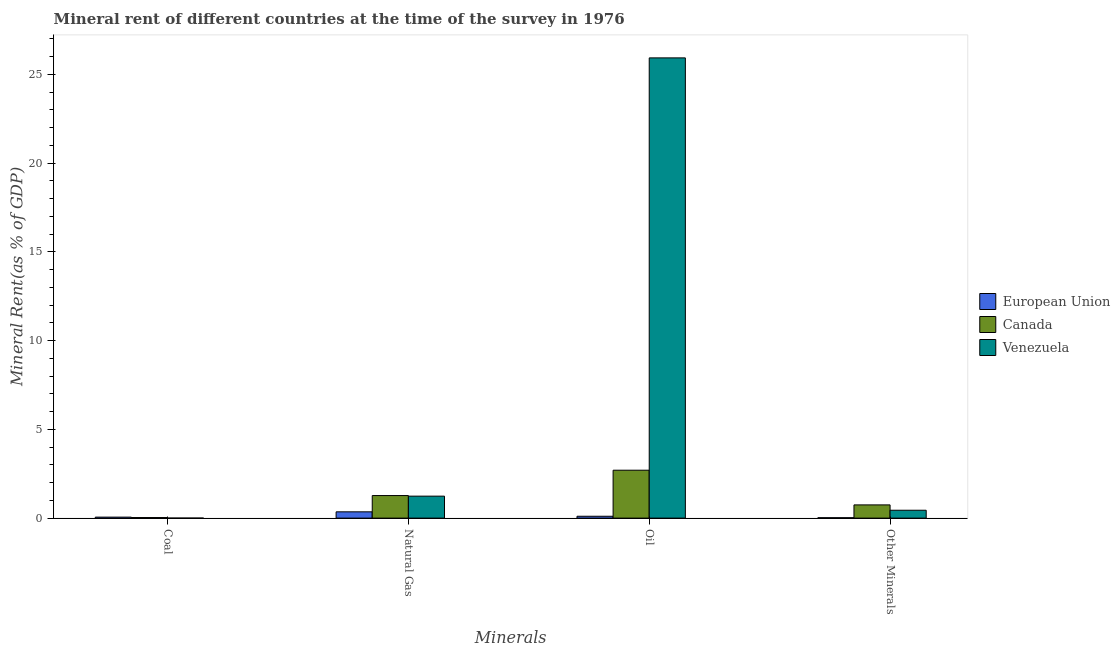How many different coloured bars are there?
Give a very brief answer. 3. Are the number of bars per tick equal to the number of legend labels?
Provide a short and direct response. Yes. Are the number of bars on each tick of the X-axis equal?
Keep it short and to the point. Yes. How many bars are there on the 1st tick from the left?
Keep it short and to the point. 3. How many bars are there on the 4th tick from the right?
Give a very brief answer. 3. What is the label of the 3rd group of bars from the left?
Your answer should be very brief. Oil. What is the oil rent in Canada?
Make the answer very short. 2.7. Across all countries, what is the maximum natural gas rent?
Provide a succinct answer. 1.27. Across all countries, what is the minimum  rent of other minerals?
Ensure brevity in your answer.  0.02. In which country was the natural gas rent maximum?
Provide a succinct answer. Canada. What is the total coal rent in the graph?
Your answer should be very brief. 0.09. What is the difference between the oil rent in Venezuela and that in Canada?
Your answer should be compact. 23.23. What is the difference between the natural gas rent in Venezuela and the coal rent in European Union?
Your response must be concise. 1.18. What is the average natural gas rent per country?
Keep it short and to the point. 0.95. What is the difference between the oil rent and coal rent in Canada?
Your answer should be compact. 2.67. What is the ratio of the oil rent in European Union to that in Canada?
Ensure brevity in your answer.  0.04. Is the oil rent in Venezuela less than that in European Union?
Ensure brevity in your answer.  No. Is the difference between the natural gas rent in Venezuela and European Union greater than the difference between the oil rent in Venezuela and European Union?
Your answer should be very brief. No. What is the difference between the highest and the second highest coal rent?
Your answer should be very brief. 0.02. What is the difference between the highest and the lowest  rent of other minerals?
Provide a succinct answer. 0.72. In how many countries, is the  rent of other minerals greater than the average  rent of other minerals taken over all countries?
Offer a very short reply. 2. Is the sum of the  rent of other minerals in Venezuela and European Union greater than the maximum natural gas rent across all countries?
Ensure brevity in your answer.  No. What does the 1st bar from the left in Oil represents?
Ensure brevity in your answer.  European Union. What does the 1st bar from the right in Natural Gas represents?
Your answer should be very brief. Venezuela. How many countries are there in the graph?
Keep it short and to the point. 3. Does the graph contain grids?
Your response must be concise. No. Where does the legend appear in the graph?
Your answer should be very brief. Center right. How many legend labels are there?
Provide a succinct answer. 3. How are the legend labels stacked?
Make the answer very short. Vertical. What is the title of the graph?
Ensure brevity in your answer.  Mineral rent of different countries at the time of the survey in 1976. What is the label or title of the X-axis?
Keep it short and to the point. Minerals. What is the label or title of the Y-axis?
Provide a succinct answer. Mineral Rent(as % of GDP). What is the Mineral Rent(as % of GDP) in European Union in Coal?
Provide a short and direct response. 0.06. What is the Mineral Rent(as % of GDP) of Canada in Coal?
Your response must be concise. 0.03. What is the Mineral Rent(as % of GDP) in Venezuela in Coal?
Provide a succinct answer. 0. What is the Mineral Rent(as % of GDP) of European Union in Natural Gas?
Your answer should be compact. 0.35. What is the Mineral Rent(as % of GDP) of Canada in Natural Gas?
Keep it short and to the point. 1.27. What is the Mineral Rent(as % of GDP) in Venezuela in Natural Gas?
Offer a very short reply. 1.24. What is the Mineral Rent(as % of GDP) in European Union in Oil?
Offer a very short reply. 0.11. What is the Mineral Rent(as % of GDP) of Canada in Oil?
Give a very brief answer. 2.7. What is the Mineral Rent(as % of GDP) in Venezuela in Oil?
Make the answer very short. 25.92. What is the Mineral Rent(as % of GDP) in European Union in Other Minerals?
Your answer should be compact. 0.02. What is the Mineral Rent(as % of GDP) of Canada in Other Minerals?
Your answer should be compact. 0.74. What is the Mineral Rent(as % of GDP) of Venezuela in Other Minerals?
Your answer should be compact. 0.44. Across all Minerals, what is the maximum Mineral Rent(as % of GDP) in European Union?
Your answer should be very brief. 0.35. Across all Minerals, what is the maximum Mineral Rent(as % of GDP) in Canada?
Provide a succinct answer. 2.7. Across all Minerals, what is the maximum Mineral Rent(as % of GDP) in Venezuela?
Ensure brevity in your answer.  25.92. Across all Minerals, what is the minimum Mineral Rent(as % of GDP) of European Union?
Provide a short and direct response. 0.02. Across all Minerals, what is the minimum Mineral Rent(as % of GDP) in Canada?
Ensure brevity in your answer.  0.03. Across all Minerals, what is the minimum Mineral Rent(as % of GDP) of Venezuela?
Ensure brevity in your answer.  0. What is the total Mineral Rent(as % of GDP) of European Union in the graph?
Keep it short and to the point. 0.54. What is the total Mineral Rent(as % of GDP) of Canada in the graph?
Your answer should be very brief. 4.75. What is the total Mineral Rent(as % of GDP) of Venezuela in the graph?
Provide a succinct answer. 27.61. What is the difference between the Mineral Rent(as % of GDP) of European Union in Coal and that in Natural Gas?
Your response must be concise. -0.3. What is the difference between the Mineral Rent(as % of GDP) of Canada in Coal and that in Natural Gas?
Make the answer very short. -1.24. What is the difference between the Mineral Rent(as % of GDP) of Venezuela in Coal and that in Natural Gas?
Offer a terse response. -1.24. What is the difference between the Mineral Rent(as % of GDP) of European Union in Coal and that in Oil?
Ensure brevity in your answer.  -0.05. What is the difference between the Mineral Rent(as % of GDP) in Canada in Coal and that in Oil?
Offer a very short reply. -2.67. What is the difference between the Mineral Rent(as % of GDP) in Venezuela in Coal and that in Oil?
Ensure brevity in your answer.  -25.92. What is the difference between the Mineral Rent(as % of GDP) of European Union in Coal and that in Other Minerals?
Your answer should be very brief. 0.03. What is the difference between the Mineral Rent(as % of GDP) in Canada in Coal and that in Other Minerals?
Provide a short and direct response. -0.71. What is the difference between the Mineral Rent(as % of GDP) of Venezuela in Coal and that in Other Minerals?
Provide a succinct answer. -0.44. What is the difference between the Mineral Rent(as % of GDP) in European Union in Natural Gas and that in Oil?
Make the answer very short. 0.25. What is the difference between the Mineral Rent(as % of GDP) in Canada in Natural Gas and that in Oil?
Your answer should be compact. -1.43. What is the difference between the Mineral Rent(as % of GDP) of Venezuela in Natural Gas and that in Oil?
Offer a terse response. -24.69. What is the difference between the Mineral Rent(as % of GDP) of European Union in Natural Gas and that in Other Minerals?
Keep it short and to the point. 0.33. What is the difference between the Mineral Rent(as % of GDP) of Canada in Natural Gas and that in Other Minerals?
Offer a very short reply. 0.53. What is the difference between the Mineral Rent(as % of GDP) in Venezuela in Natural Gas and that in Other Minerals?
Ensure brevity in your answer.  0.79. What is the difference between the Mineral Rent(as % of GDP) of European Union in Oil and that in Other Minerals?
Make the answer very short. 0.08. What is the difference between the Mineral Rent(as % of GDP) in Canada in Oil and that in Other Minerals?
Make the answer very short. 1.95. What is the difference between the Mineral Rent(as % of GDP) in Venezuela in Oil and that in Other Minerals?
Offer a terse response. 25.48. What is the difference between the Mineral Rent(as % of GDP) in European Union in Coal and the Mineral Rent(as % of GDP) in Canada in Natural Gas?
Ensure brevity in your answer.  -1.22. What is the difference between the Mineral Rent(as % of GDP) in European Union in Coal and the Mineral Rent(as % of GDP) in Venezuela in Natural Gas?
Give a very brief answer. -1.18. What is the difference between the Mineral Rent(as % of GDP) in Canada in Coal and the Mineral Rent(as % of GDP) in Venezuela in Natural Gas?
Provide a succinct answer. -1.21. What is the difference between the Mineral Rent(as % of GDP) in European Union in Coal and the Mineral Rent(as % of GDP) in Canada in Oil?
Provide a succinct answer. -2.64. What is the difference between the Mineral Rent(as % of GDP) in European Union in Coal and the Mineral Rent(as % of GDP) in Venezuela in Oil?
Offer a very short reply. -25.87. What is the difference between the Mineral Rent(as % of GDP) in Canada in Coal and the Mineral Rent(as % of GDP) in Venezuela in Oil?
Offer a very short reply. -25.89. What is the difference between the Mineral Rent(as % of GDP) in European Union in Coal and the Mineral Rent(as % of GDP) in Canada in Other Minerals?
Provide a succinct answer. -0.69. What is the difference between the Mineral Rent(as % of GDP) in European Union in Coal and the Mineral Rent(as % of GDP) in Venezuela in Other Minerals?
Provide a short and direct response. -0.39. What is the difference between the Mineral Rent(as % of GDP) of Canada in Coal and the Mineral Rent(as % of GDP) of Venezuela in Other Minerals?
Your answer should be compact. -0.41. What is the difference between the Mineral Rent(as % of GDP) in European Union in Natural Gas and the Mineral Rent(as % of GDP) in Canada in Oil?
Ensure brevity in your answer.  -2.34. What is the difference between the Mineral Rent(as % of GDP) in European Union in Natural Gas and the Mineral Rent(as % of GDP) in Venezuela in Oil?
Your answer should be very brief. -25.57. What is the difference between the Mineral Rent(as % of GDP) in Canada in Natural Gas and the Mineral Rent(as % of GDP) in Venezuela in Oil?
Ensure brevity in your answer.  -24.65. What is the difference between the Mineral Rent(as % of GDP) of European Union in Natural Gas and the Mineral Rent(as % of GDP) of Canada in Other Minerals?
Give a very brief answer. -0.39. What is the difference between the Mineral Rent(as % of GDP) of European Union in Natural Gas and the Mineral Rent(as % of GDP) of Venezuela in Other Minerals?
Keep it short and to the point. -0.09. What is the difference between the Mineral Rent(as % of GDP) in Canada in Natural Gas and the Mineral Rent(as % of GDP) in Venezuela in Other Minerals?
Offer a terse response. 0.83. What is the difference between the Mineral Rent(as % of GDP) of European Union in Oil and the Mineral Rent(as % of GDP) of Canada in Other Minerals?
Make the answer very short. -0.64. What is the difference between the Mineral Rent(as % of GDP) in European Union in Oil and the Mineral Rent(as % of GDP) in Venezuela in Other Minerals?
Make the answer very short. -0.34. What is the difference between the Mineral Rent(as % of GDP) of Canada in Oil and the Mineral Rent(as % of GDP) of Venezuela in Other Minerals?
Offer a terse response. 2.25. What is the average Mineral Rent(as % of GDP) of European Union per Minerals?
Offer a terse response. 0.13. What is the average Mineral Rent(as % of GDP) in Canada per Minerals?
Offer a terse response. 1.19. What is the average Mineral Rent(as % of GDP) in Venezuela per Minerals?
Make the answer very short. 6.9. What is the difference between the Mineral Rent(as % of GDP) in European Union and Mineral Rent(as % of GDP) in Canada in Coal?
Provide a succinct answer. 0.02. What is the difference between the Mineral Rent(as % of GDP) of European Union and Mineral Rent(as % of GDP) of Venezuela in Coal?
Offer a terse response. 0.05. What is the difference between the Mineral Rent(as % of GDP) of Canada and Mineral Rent(as % of GDP) of Venezuela in Coal?
Make the answer very short. 0.03. What is the difference between the Mineral Rent(as % of GDP) of European Union and Mineral Rent(as % of GDP) of Canada in Natural Gas?
Your answer should be very brief. -0.92. What is the difference between the Mineral Rent(as % of GDP) of European Union and Mineral Rent(as % of GDP) of Venezuela in Natural Gas?
Your answer should be compact. -0.88. What is the difference between the Mineral Rent(as % of GDP) of Canada and Mineral Rent(as % of GDP) of Venezuela in Natural Gas?
Ensure brevity in your answer.  0.03. What is the difference between the Mineral Rent(as % of GDP) in European Union and Mineral Rent(as % of GDP) in Canada in Oil?
Offer a very short reply. -2.59. What is the difference between the Mineral Rent(as % of GDP) in European Union and Mineral Rent(as % of GDP) in Venezuela in Oil?
Offer a terse response. -25.82. What is the difference between the Mineral Rent(as % of GDP) of Canada and Mineral Rent(as % of GDP) of Venezuela in Oil?
Give a very brief answer. -23.23. What is the difference between the Mineral Rent(as % of GDP) in European Union and Mineral Rent(as % of GDP) in Canada in Other Minerals?
Make the answer very short. -0.72. What is the difference between the Mineral Rent(as % of GDP) of European Union and Mineral Rent(as % of GDP) of Venezuela in Other Minerals?
Offer a very short reply. -0.42. What is the difference between the Mineral Rent(as % of GDP) of Canada and Mineral Rent(as % of GDP) of Venezuela in Other Minerals?
Your response must be concise. 0.3. What is the ratio of the Mineral Rent(as % of GDP) of European Union in Coal to that in Natural Gas?
Your answer should be compact. 0.16. What is the ratio of the Mineral Rent(as % of GDP) in Canada in Coal to that in Natural Gas?
Offer a terse response. 0.02. What is the ratio of the Mineral Rent(as % of GDP) in Venezuela in Coal to that in Natural Gas?
Your answer should be very brief. 0. What is the ratio of the Mineral Rent(as % of GDP) of European Union in Coal to that in Oil?
Ensure brevity in your answer.  0.53. What is the ratio of the Mineral Rent(as % of GDP) in Canada in Coal to that in Oil?
Keep it short and to the point. 0.01. What is the ratio of the Mineral Rent(as % of GDP) in European Union in Coal to that in Other Minerals?
Keep it short and to the point. 2.44. What is the ratio of the Mineral Rent(as % of GDP) in Canada in Coal to that in Other Minerals?
Your answer should be compact. 0.04. What is the ratio of the Mineral Rent(as % of GDP) of Venezuela in Coal to that in Other Minerals?
Ensure brevity in your answer.  0. What is the ratio of the Mineral Rent(as % of GDP) in European Union in Natural Gas to that in Oil?
Keep it short and to the point. 3.37. What is the ratio of the Mineral Rent(as % of GDP) in Canada in Natural Gas to that in Oil?
Offer a terse response. 0.47. What is the ratio of the Mineral Rent(as % of GDP) in Venezuela in Natural Gas to that in Oil?
Give a very brief answer. 0.05. What is the ratio of the Mineral Rent(as % of GDP) in European Union in Natural Gas to that in Other Minerals?
Keep it short and to the point. 15.54. What is the ratio of the Mineral Rent(as % of GDP) in Canada in Natural Gas to that in Other Minerals?
Give a very brief answer. 1.71. What is the ratio of the Mineral Rent(as % of GDP) of Venezuela in Natural Gas to that in Other Minerals?
Your answer should be compact. 2.79. What is the ratio of the Mineral Rent(as % of GDP) of European Union in Oil to that in Other Minerals?
Your answer should be very brief. 4.61. What is the ratio of the Mineral Rent(as % of GDP) in Canada in Oil to that in Other Minerals?
Provide a succinct answer. 3.62. What is the ratio of the Mineral Rent(as % of GDP) of Venezuela in Oil to that in Other Minerals?
Provide a succinct answer. 58.47. What is the difference between the highest and the second highest Mineral Rent(as % of GDP) in European Union?
Make the answer very short. 0.25. What is the difference between the highest and the second highest Mineral Rent(as % of GDP) in Canada?
Offer a very short reply. 1.43. What is the difference between the highest and the second highest Mineral Rent(as % of GDP) of Venezuela?
Give a very brief answer. 24.69. What is the difference between the highest and the lowest Mineral Rent(as % of GDP) in European Union?
Ensure brevity in your answer.  0.33. What is the difference between the highest and the lowest Mineral Rent(as % of GDP) in Canada?
Your response must be concise. 2.67. What is the difference between the highest and the lowest Mineral Rent(as % of GDP) of Venezuela?
Keep it short and to the point. 25.92. 